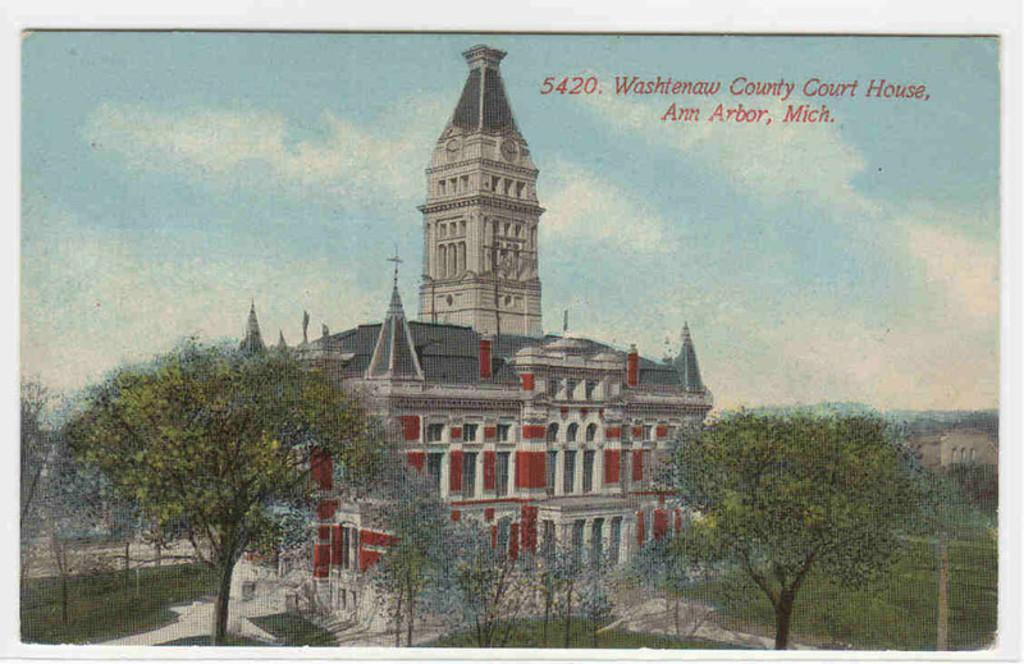What type of visual is depicted in the image? The image appears to be a poster. What is the main subject of the poster? There is a building in the middle of the poster. What type of vegetation is at the bottom of the poster? There are trees at the bottom of the poster. What is visible at the top of the poster? The sky is visible at the top of the poster. How many masks the view of the building in the poster? There is no baseball or mask present in the image; it features a building, trees, and the sky. 